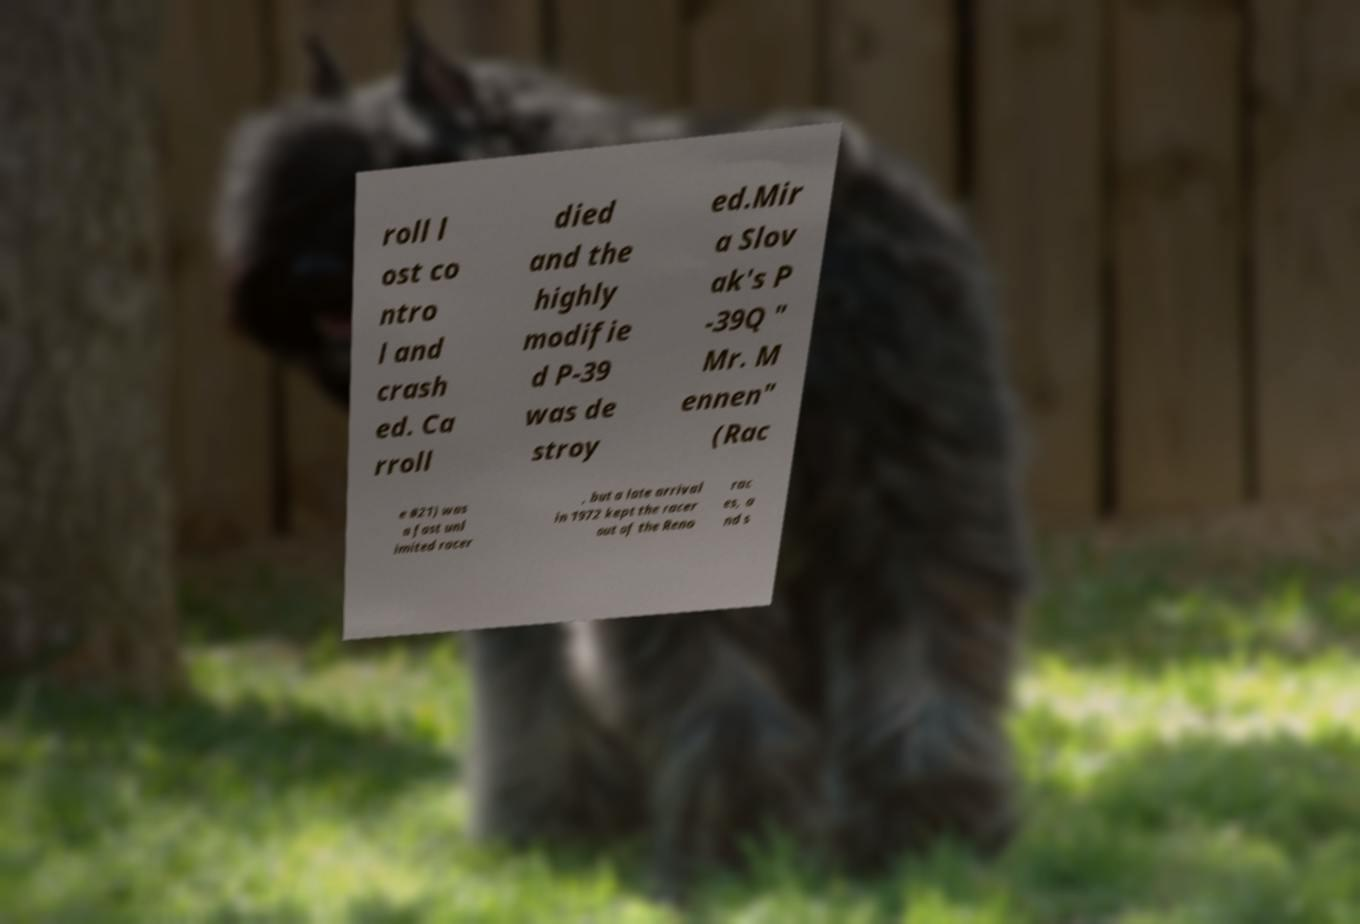Can you accurately transcribe the text from the provided image for me? roll l ost co ntro l and crash ed. Ca rroll died and the highly modifie d P-39 was de stroy ed.Mir a Slov ak's P -39Q " Mr. M ennen" (Rac e #21) was a fast unl imited racer , but a late arrival in 1972 kept the racer out of the Reno rac es, a nd s 